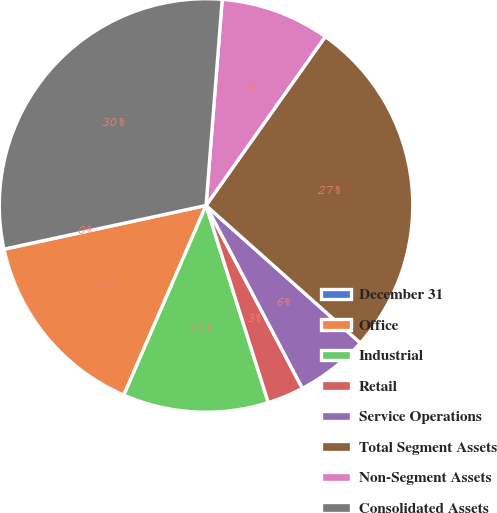<chart> <loc_0><loc_0><loc_500><loc_500><pie_chart><fcel>December 31<fcel>Office<fcel>Industrial<fcel>Retail<fcel>Service Operations<fcel>Total Segment Assets<fcel>Non-Segment Assets<fcel>Consolidated Assets<nl><fcel>0.01%<fcel>15.09%<fcel>11.38%<fcel>2.85%<fcel>5.7%<fcel>26.8%<fcel>8.54%<fcel>29.64%<nl></chart> 